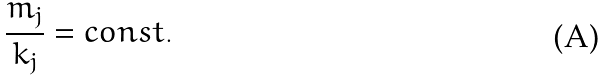<formula> <loc_0><loc_0><loc_500><loc_500>\frac { m _ { j } } { k _ { j } } = c o n s t .</formula> 